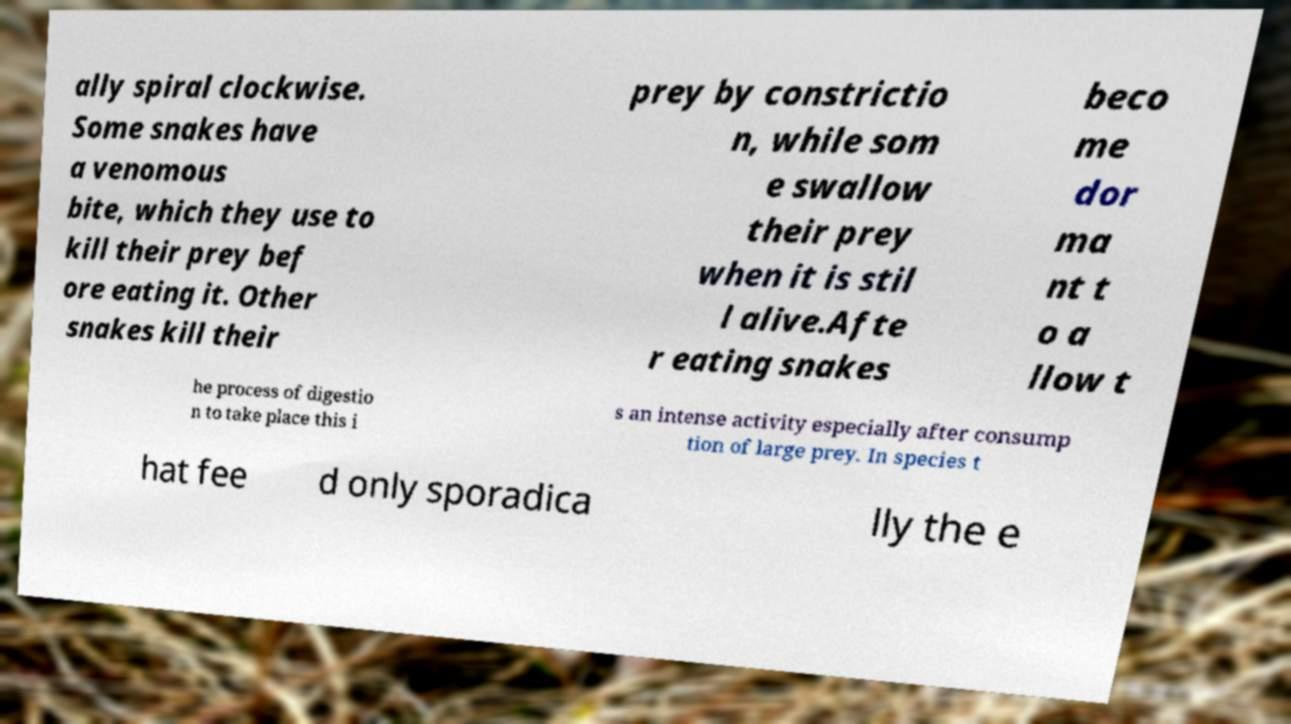Please identify and transcribe the text found in this image. ally spiral clockwise. Some snakes have a venomous bite, which they use to kill their prey bef ore eating it. Other snakes kill their prey by constrictio n, while som e swallow their prey when it is stil l alive.Afte r eating snakes beco me dor ma nt t o a llow t he process of digestio n to take place this i s an intense activity especially after consump tion of large prey. In species t hat fee d only sporadica lly the e 